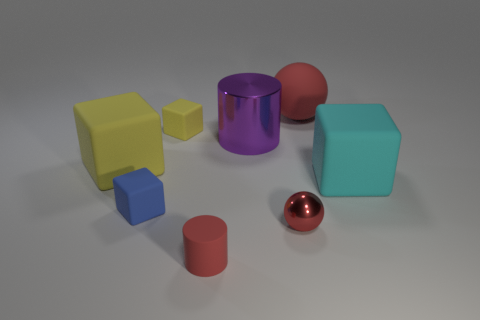Subtract all yellow cylinders. How many yellow cubes are left? 2 Subtract 2 blocks. How many blocks are left? 2 Subtract all small blue blocks. How many blocks are left? 3 Subtract all blue blocks. How many blocks are left? 3 Add 2 tiny matte objects. How many objects exist? 10 Subtract all brown blocks. Subtract all green cylinders. How many blocks are left? 4 Subtract all balls. How many objects are left? 6 Subtract all red metallic things. Subtract all blue matte objects. How many objects are left? 6 Add 2 large cyan things. How many large cyan things are left? 3 Add 3 big purple matte blocks. How many big purple matte blocks exist? 3 